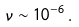Convert formula to latex. <formula><loc_0><loc_0><loc_500><loc_500>\nu \sim 1 0 ^ { - 6 } \, .</formula> 